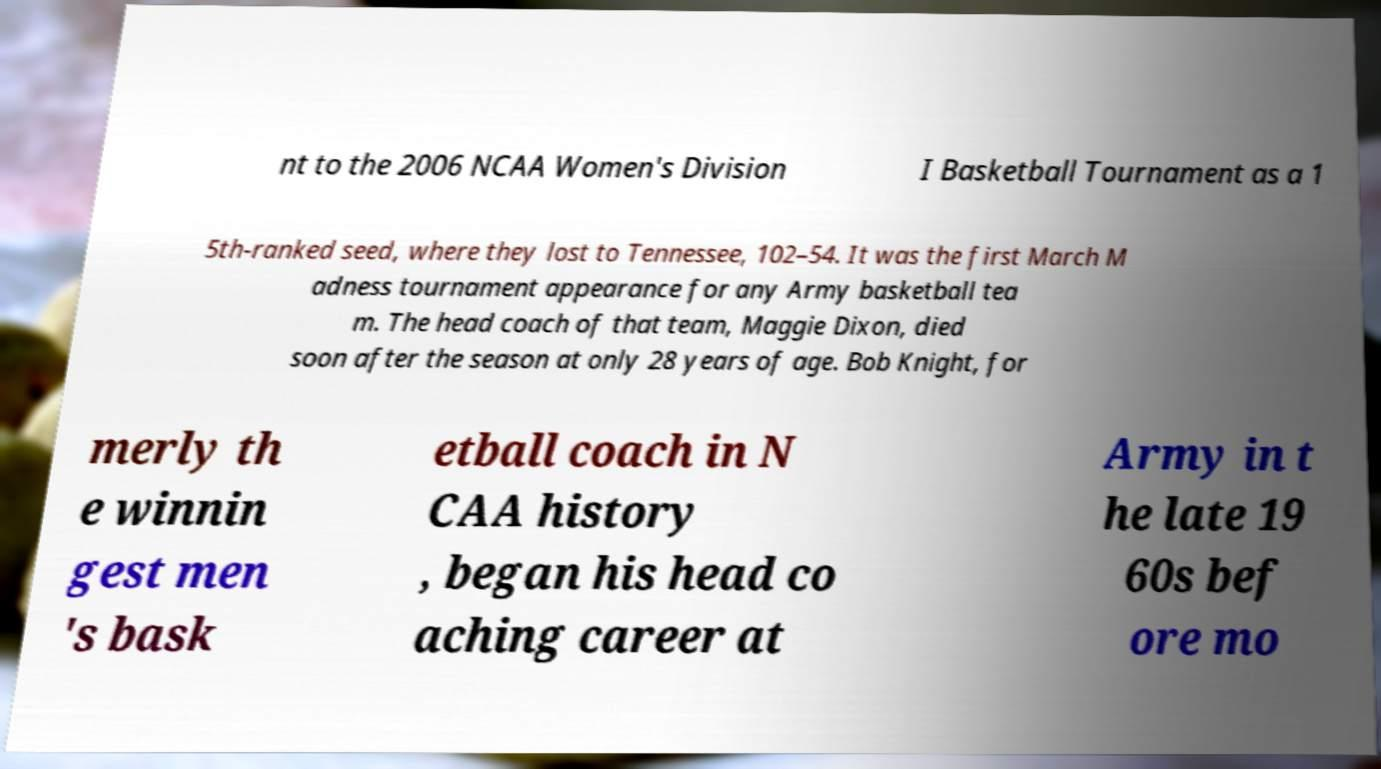For documentation purposes, I need the text within this image transcribed. Could you provide that? nt to the 2006 NCAA Women's Division I Basketball Tournament as a 1 5th-ranked seed, where they lost to Tennessee, 102–54. It was the first March M adness tournament appearance for any Army basketball tea m. The head coach of that team, Maggie Dixon, died soon after the season at only 28 years of age. Bob Knight, for merly th e winnin gest men 's bask etball coach in N CAA history , began his head co aching career at Army in t he late 19 60s bef ore mo 